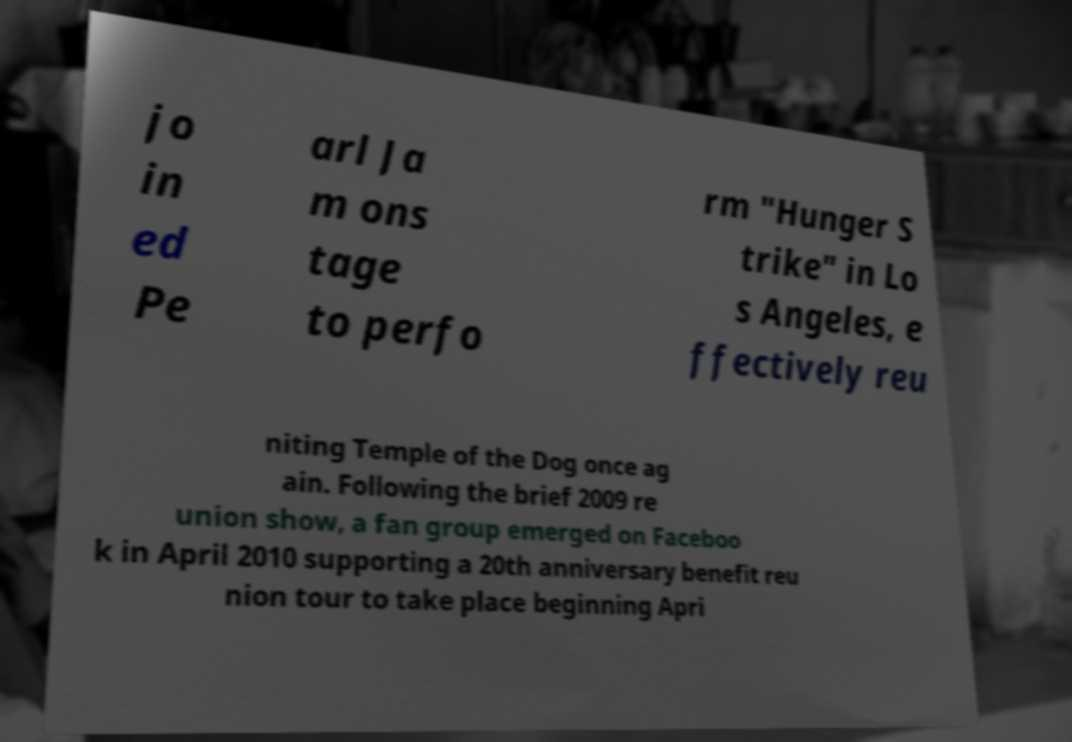Could you extract and type out the text from this image? jo in ed Pe arl Ja m ons tage to perfo rm "Hunger S trike" in Lo s Angeles, e ffectively reu niting Temple of the Dog once ag ain. Following the brief 2009 re union show, a fan group emerged on Faceboo k in April 2010 supporting a 20th anniversary benefit reu nion tour to take place beginning Apri 